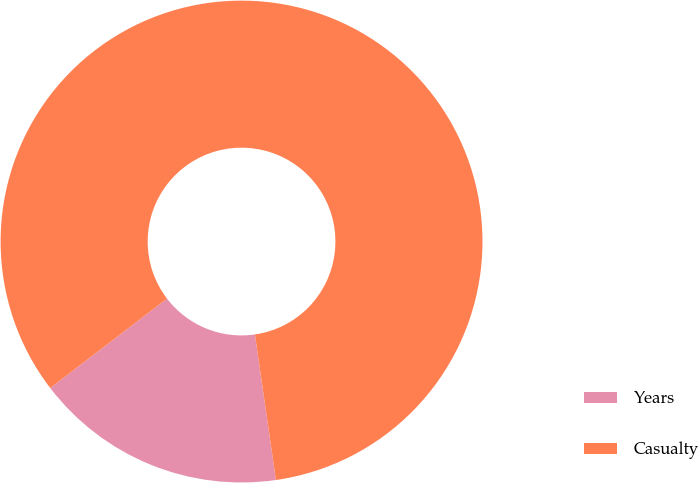Convert chart to OTSL. <chart><loc_0><loc_0><loc_500><loc_500><pie_chart><fcel>Years<fcel>Casualty<nl><fcel>16.88%<fcel>83.12%<nl></chart> 